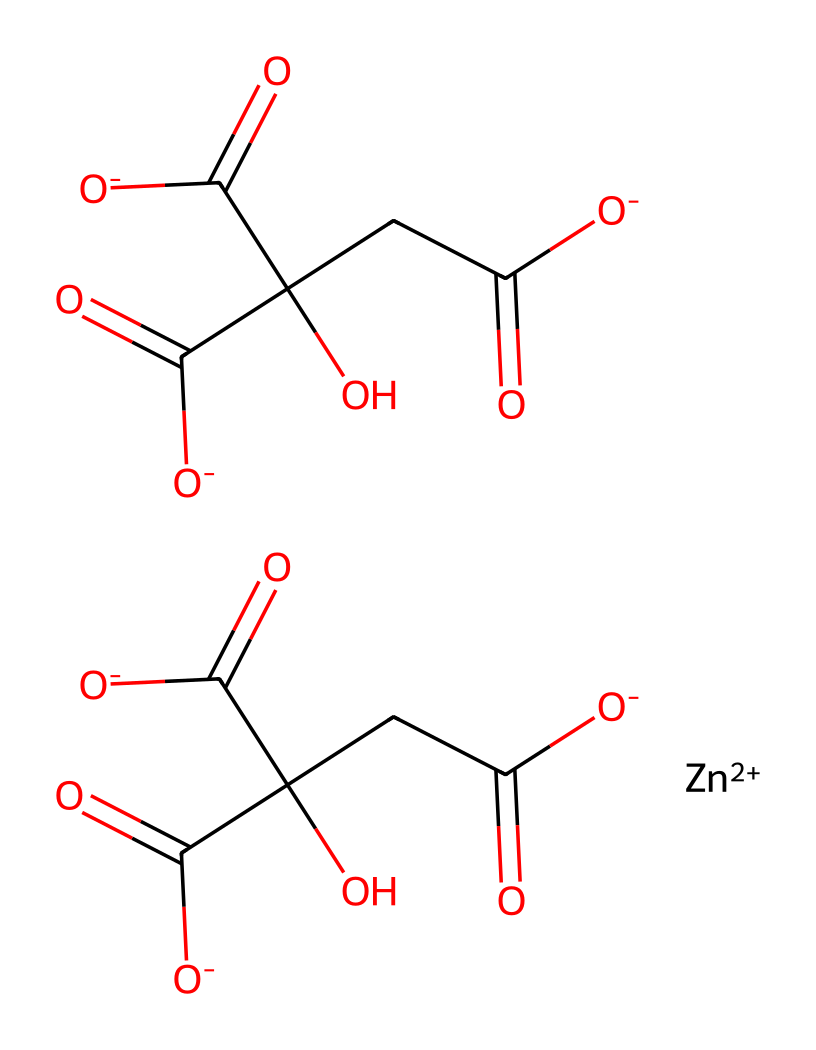What is the central metal ion in this coordination compound? The provided SMILES notation indicates the presence of [Zn+2], which signifies that zinc is the central metal ion in the coordination compound.
Answer: zinc How many carboxylate groups are present in this structure? By examining the SMILES, there are multiple instances of C(=O)[O-], indicating the presence of carboxylate segments. Counting them yields four carboxylate groups in total.
Answer: four What type of bonding occurs between the zinc ion and the attached groups? The connection between the zinc ion and the surrounding carboxylate groups is a coordination bond, where the metal accepts electron pairs from the anionic groups.
Answer: coordination bond What type of compound is represented by this coordination complex? The structure is indicative of a coordination complex due to the presence of a central metal ion coordinated to multiple ligands (in this case, carboxylates).
Answer: coordination complex How might this coordination complex benefit sensitive skin formulations? The zinc ion is known for its soothing properties and anti-inflammatory effects, making this complex potentially beneficial in hypoallergenic cosmetic formulations for sensitive skin.
Answer: soothing properties 